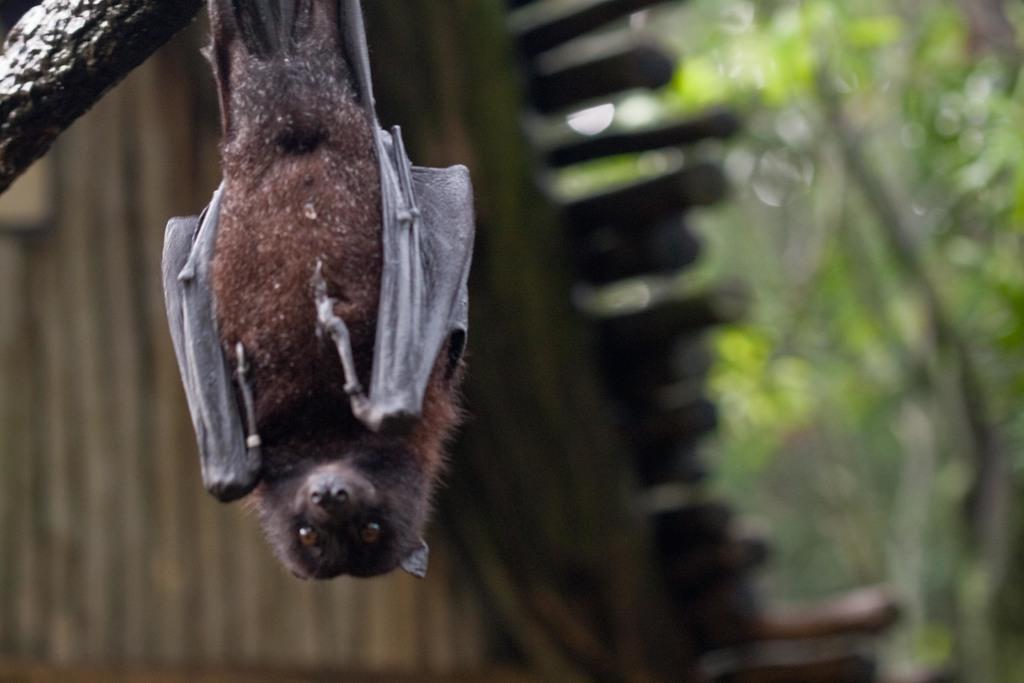Please provide a concise description of this image. This picture is clicked outside. On the left we can see a bat seems to be hanging on the branch of a tree. In the background we can see the green leaves and some other objects. 